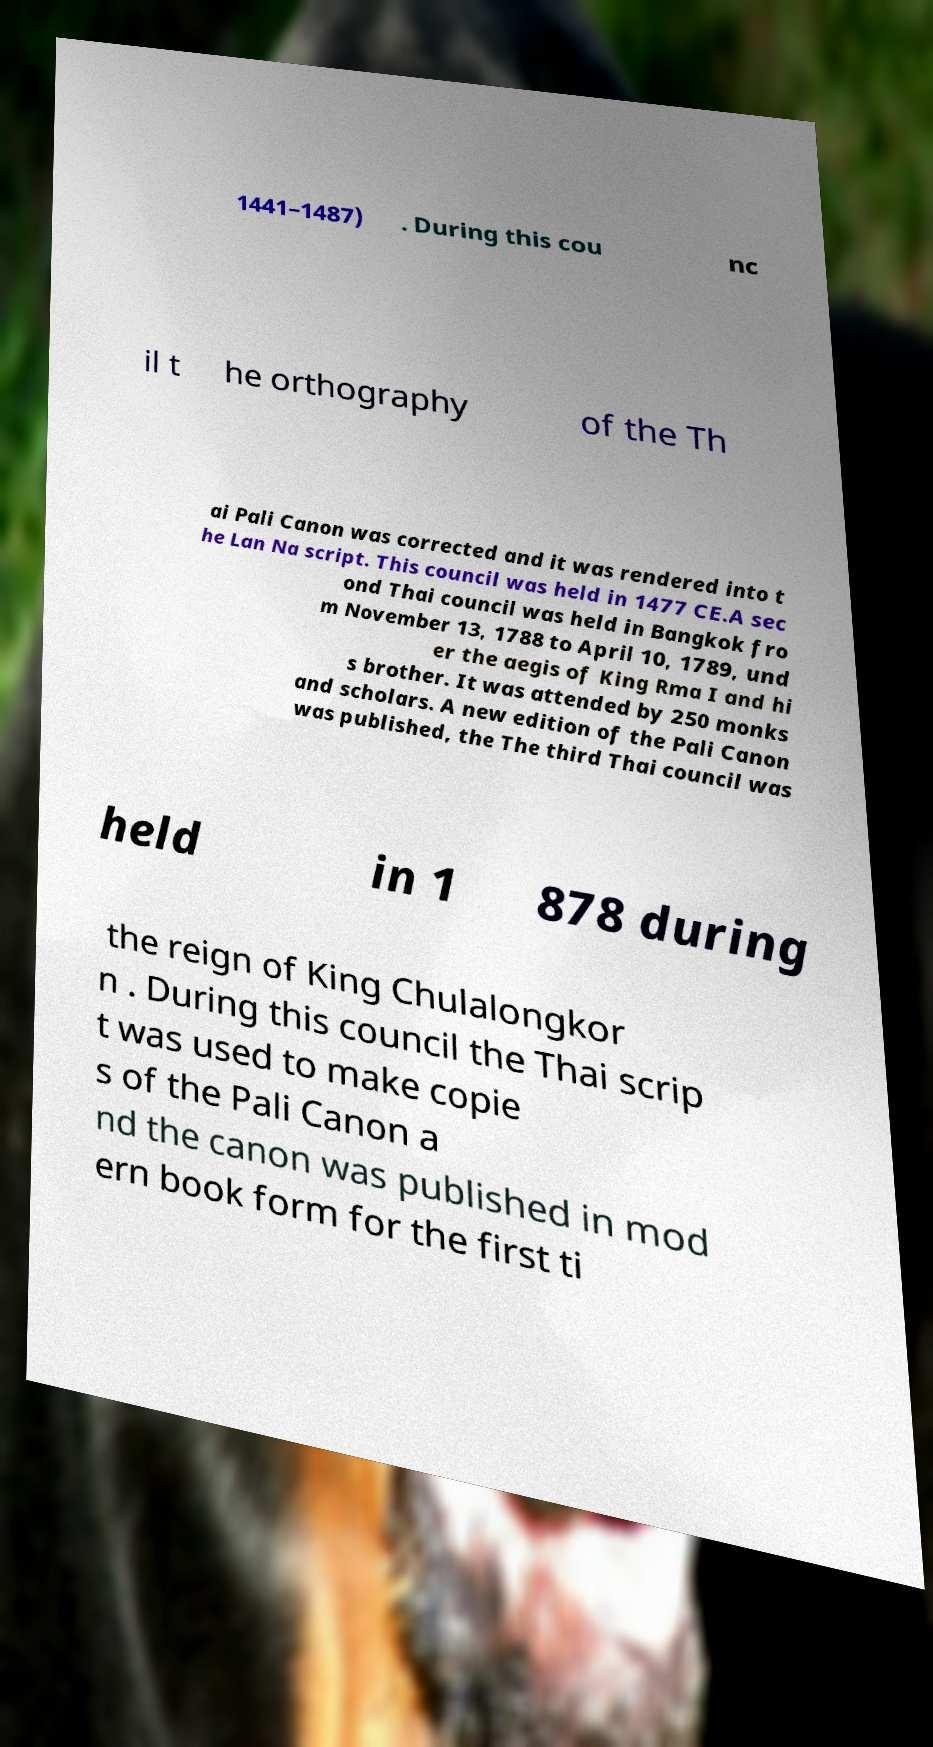I need the written content from this picture converted into text. Can you do that? 1441–1487) . During this cou nc il t he orthography of the Th ai Pali Canon was corrected and it was rendered into t he Lan Na script. This council was held in 1477 CE.A sec ond Thai council was held in Bangkok fro m November 13, 1788 to April 10, 1789, und er the aegis of King Rma I and hi s brother. It was attended by 250 monks and scholars. A new edition of the Pali Canon was published, the The third Thai council was held in 1 878 during the reign of King Chulalongkor n . During this council the Thai scrip t was used to make copie s of the Pali Canon a nd the canon was published in mod ern book form for the first ti 